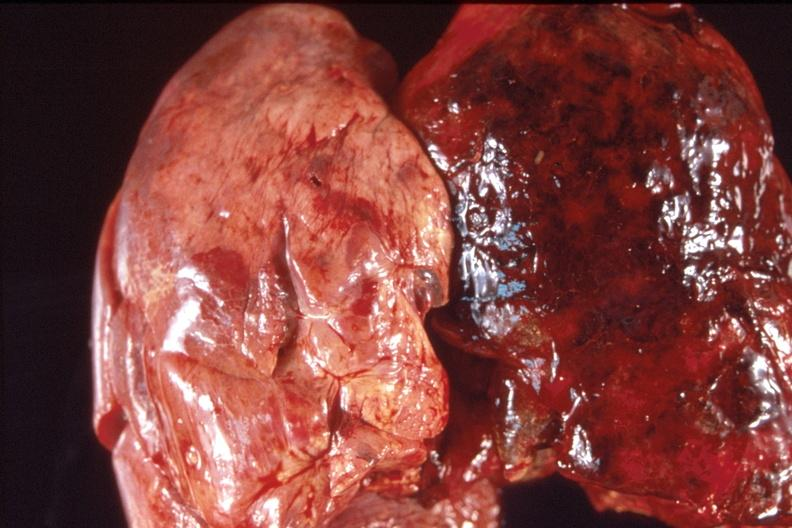where is this?
Answer the question using a single word or phrase. Lung 